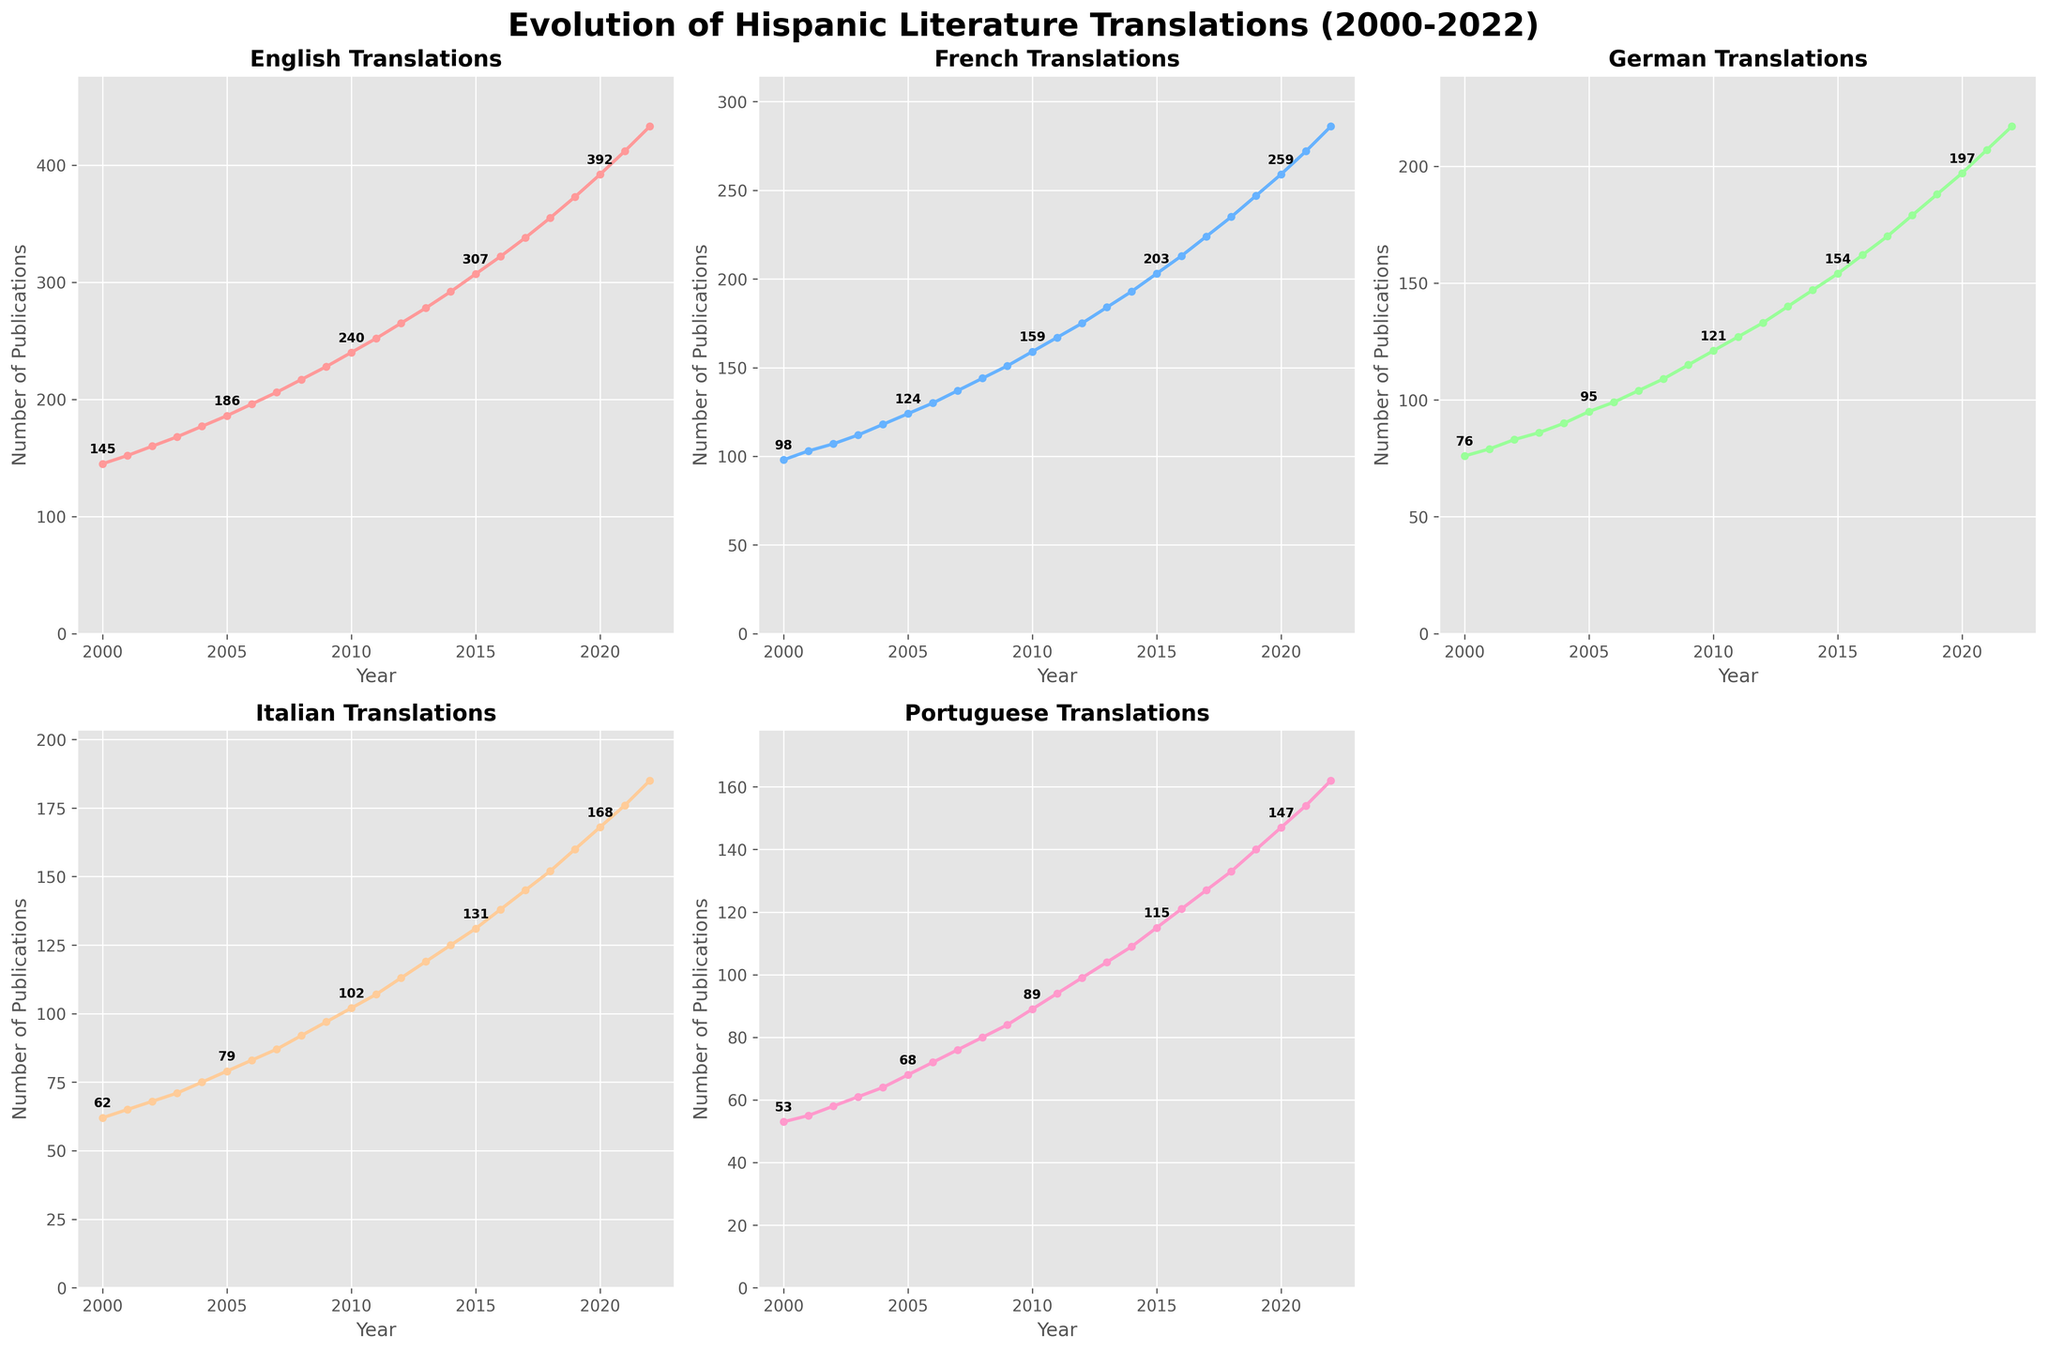Which language showed the highest number of translations in 2022? Check the subplot for each language and observe the final point on the line graph corresponding to the year 2022. The highest value is for English.
Answer: English In which year did German translations surpass 100 publications? Look at the German subplot and find when the line graph crosses the 100 mark on the y-axis. It happens in 2007.
Answer: 2007 By how much did the number of Italian translations increase from 2005 to 2015? Check the Italian subplot and note the values for 2005 (79) and 2015 (131). Calculate the difference: 131 - 79.
Answer: 52 Which language had the least number of translations in 2000? Look at the subplots for 2000 and compare the values. The lowest number is for Portuguese.
Answer: Portuguese What is the average number of French translations from 2010 to 2020? Find the French subplot and list the values from 2010 to 2020: 159, 167, 175, 184, 193, 203, 213, 224, 235, 247, 259. Sum these values and divide by the number of years (11). The sum is 2255, so the average is 2255 / 11 ≈ 204.09.
Answer: ~204 Did Portuguese translations double from 2000 to 2022? Check the Portuguese subplot for values in 2000 (53) and 2022 (162). Calculate if 162 is at least twice 53 (53 * 2 = 106). Since 162 is greater than 106, the translations more than doubled.
Answer: Yes Which year saw the largest absolute increase in English translations? Examine the yearly differences in the English subplot. The largest yearly increase occurred from 2021 (412) to 2022 (433), with an increase of 21 translations.
Answer: 2022 Are German and Italian translations ever equal between 2000 and 2022? Check the German and Italian subplots and see if their lines intersect or have the same y-value at any year. They do not equal each other during this period.
Answer: No How many languages had more than 150 translations in 2010? Look at each subplot for the year 2010 and count the languages with values greater than 150: English (240), French (159). Only two languages meet this criterion.
Answer: 2 